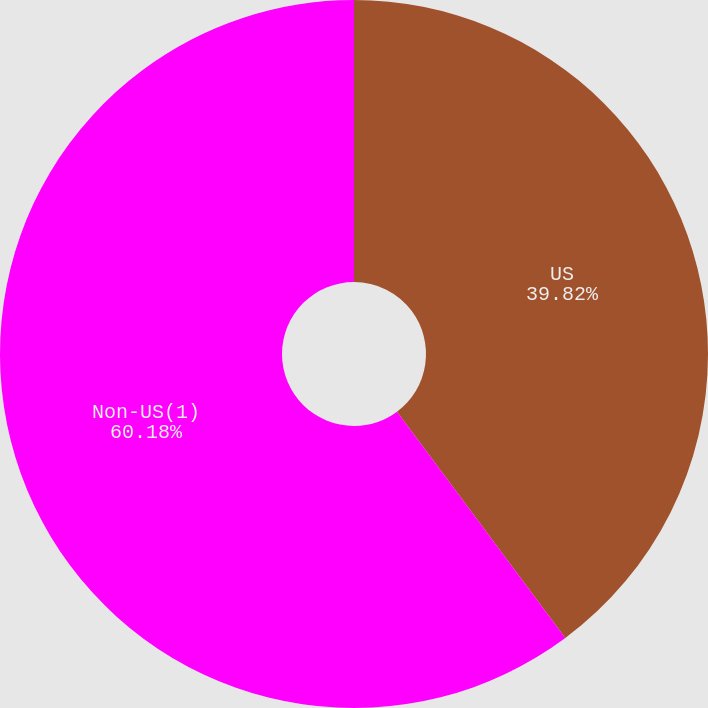<chart> <loc_0><loc_0><loc_500><loc_500><pie_chart><fcel>US<fcel>Non-US(1)<nl><fcel>39.82%<fcel>60.18%<nl></chart> 